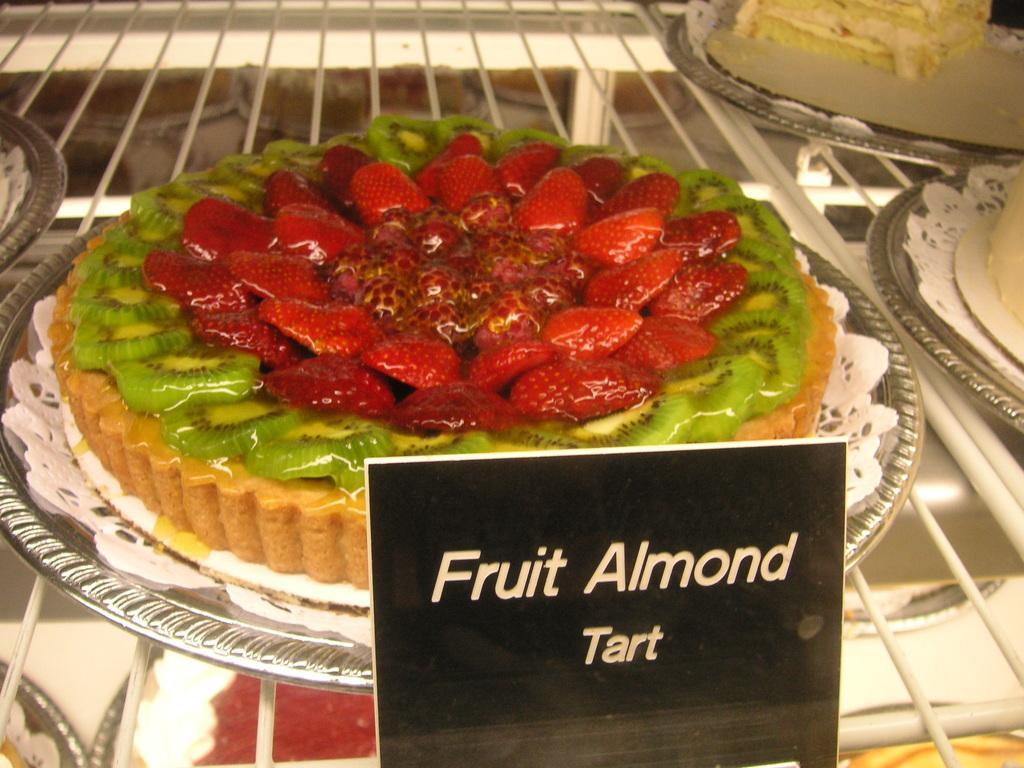Describe this image in one or two sentences. In this image we can see different types of cakes placed on the table along with the name boards. 